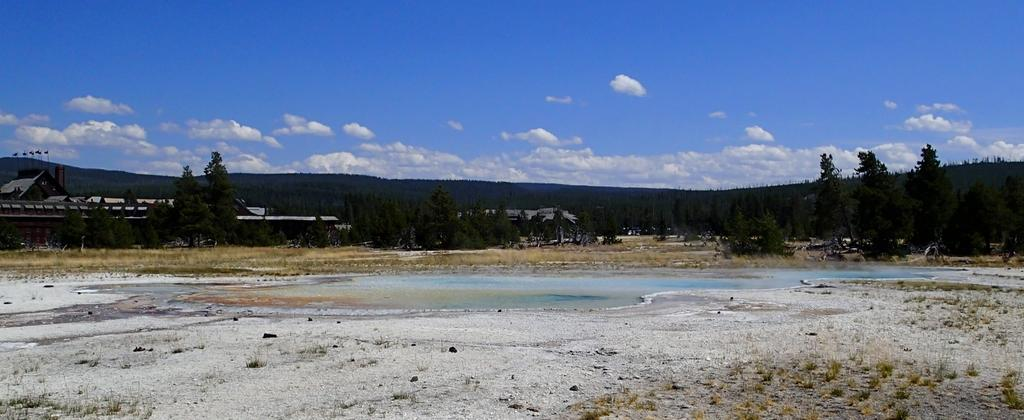What is present in the image that represents a natural resource? There is water in the image. What type of vegetation can be seen in the image? There are trees in the image. Where are the houses located in the image? The houses are on the left side of the image. What can be seen in the distance in the image? There are hills in the background of the image. What is visible in the sky in the image? The sky is visible in the background of the image, and there are clouds in the sky. Can you see a shop in the image? There is no shop present in the image. Are there any ghosts visible in the image? There are no ghosts present in the image. 